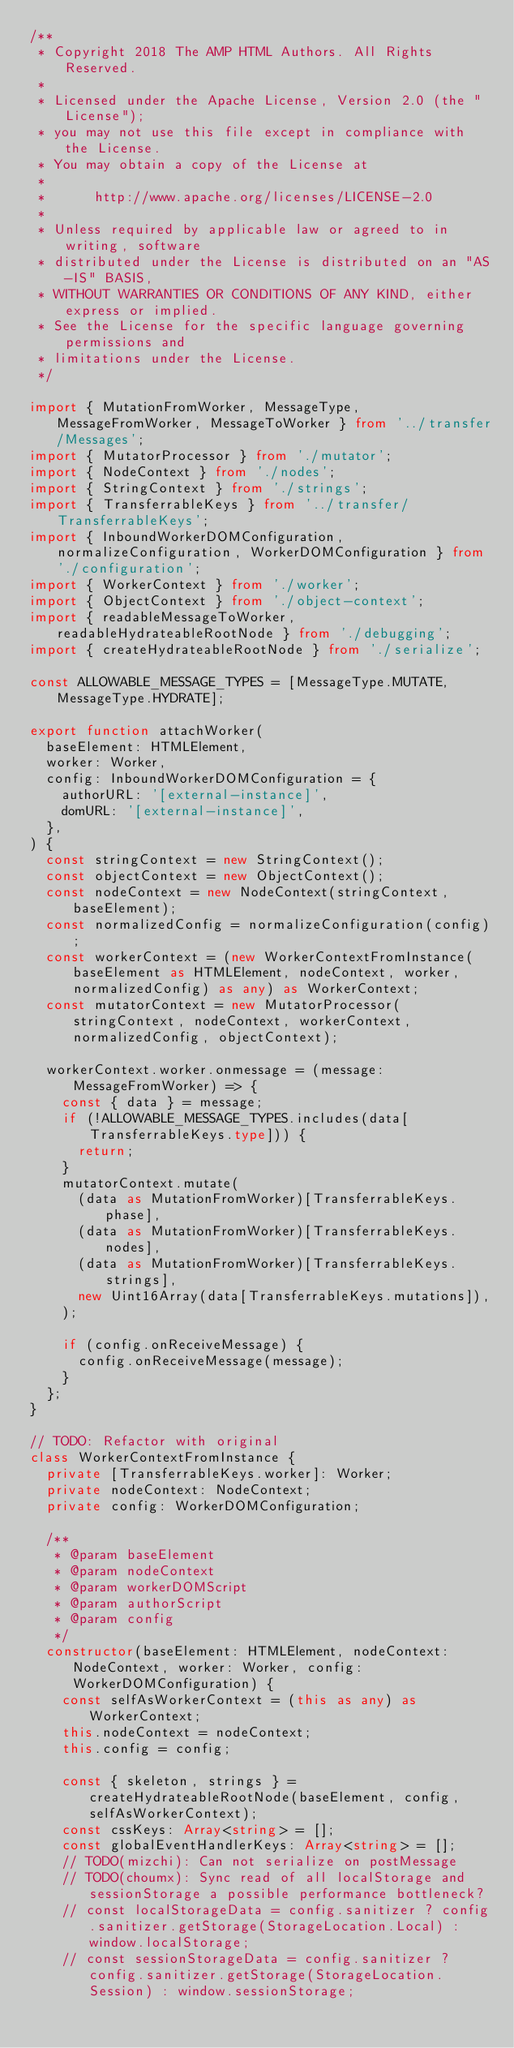<code> <loc_0><loc_0><loc_500><loc_500><_TypeScript_>/**
 * Copyright 2018 The AMP HTML Authors. All Rights Reserved.
 *
 * Licensed under the Apache License, Version 2.0 (the "License");
 * you may not use this file except in compliance with the License.
 * You may obtain a copy of the License at
 *
 *      http://www.apache.org/licenses/LICENSE-2.0
 *
 * Unless required by applicable law or agreed to in writing, software
 * distributed under the License is distributed on an "AS-IS" BASIS,
 * WITHOUT WARRANTIES OR CONDITIONS OF ANY KIND, either express or implied.
 * See the License for the specific language governing permissions and
 * limitations under the License.
 */

import { MutationFromWorker, MessageType, MessageFromWorker, MessageToWorker } from '../transfer/Messages';
import { MutatorProcessor } from './mutator';
import { NodeContext } from './nodes';
import { StringContext } from './strings';
import { TransferrableKeys } from '../transfer/TransferrableKeys';
import { InboundWorkerDOMConfiguration, normalizeConfiguration, WorkerDOMConfiguration } from './configuration';
import { WorkerContext } from './worker';
import { ObjectContext } from './object-context';
import { readableMessageToWorker, readableHydrateableRootNode } from './debugging';
import { createHydrateableRootNode } from './serialize';

const ALLOWABLE_MESSAGE_TYPES = [MessageType.MUTATE, MessageType.HYDRATE];

export function attachWorker(
  baseElement: HTMLElement,
  worker: Worker,
  config: InboundWorkerDOMConfiguration = {
    authorURL: '[external-instance]',
    domURL: '[external-instance]',
  },
) {
  const stringContext = new StringContext();
  const objectContext = new ObjectContext();
  const nodeContext = new NodeContext(stringContext, baseElement);
  const normalizedConfig = normalizeConfiguration(config);
  const workerContext = (new WorkerContextFromInstance(baseElement as HTMLElement, nodeContext, worker, normalizedConfig) as any) as WorkerContext;
  const mutatorContext = new MutatorProcessor(stringContext, nodeContext, workerContext, normalizedConfig, objectContext);

  workerContext.worker.onmessage = (message: MessageFromWorker) => {
    const { data } = message;
    if (!ALLOWABLE_MESSAGE_TYPES.includes(data[TransferrableKeys.type])) {
      return;
    }
    mutatorContext.mutate(
      (data as MutationFromWorker)[TransferrableKeys.phase],
      (data as MutationFromWorker)[TransferrableKeys.nodes],
      (data as MutationFromWorker)[TransferrableKeys.strings],
      new Uint16Array(data[TransferrableKeys.mutations]),
    );

    if (config.onReceiveMessage) {
      config.onReceiveMessage(message);
    }
  };
}

// TODO: Refactor with original
class WorkerContextFromInstance {
  private [TransferrableKeys.worker]: Worker;
  private nodeContext: NodeContext;
  private config: WorkerDOMConfiguration;

  /**
   * @param baseElement
   * @param nodeContext
   * @param workerDOMScript
   * @param authorScript
   * @param config
   */
  constructor(baseElement: HTMLElement, nodeContext: NodeContext, worker: Worker, config: WorkerDOMConfiguration) {
    const selfAsWorkerContext = (this as any) as WorkerContext;
    this.nodeContext = nodeContext;
    this.config = config;

    const { skeleton, strings } = createHydrateableRootNode(baseElement, config, selfAsWorkerContext);
    const cssKeys: Array<string> = [];
    const globalEventHandlerKeys: Array<string> = [];
    // TODO(mizchi): Can not serialize on postMessage
    // TODO(choumx): Sync read of all localStorage and sessionStorage a possible performance bottleneck?
    // const localStorageData = config.sanitizer ? config.sanitizer.getStorage(StorageLocation.Local) : window.localStorage;
    // const sessionStorageData = config.sanitizer ? config.sanitizer.getStorage(StorageLocation.Session) : window.sessionStorage;
</code> 